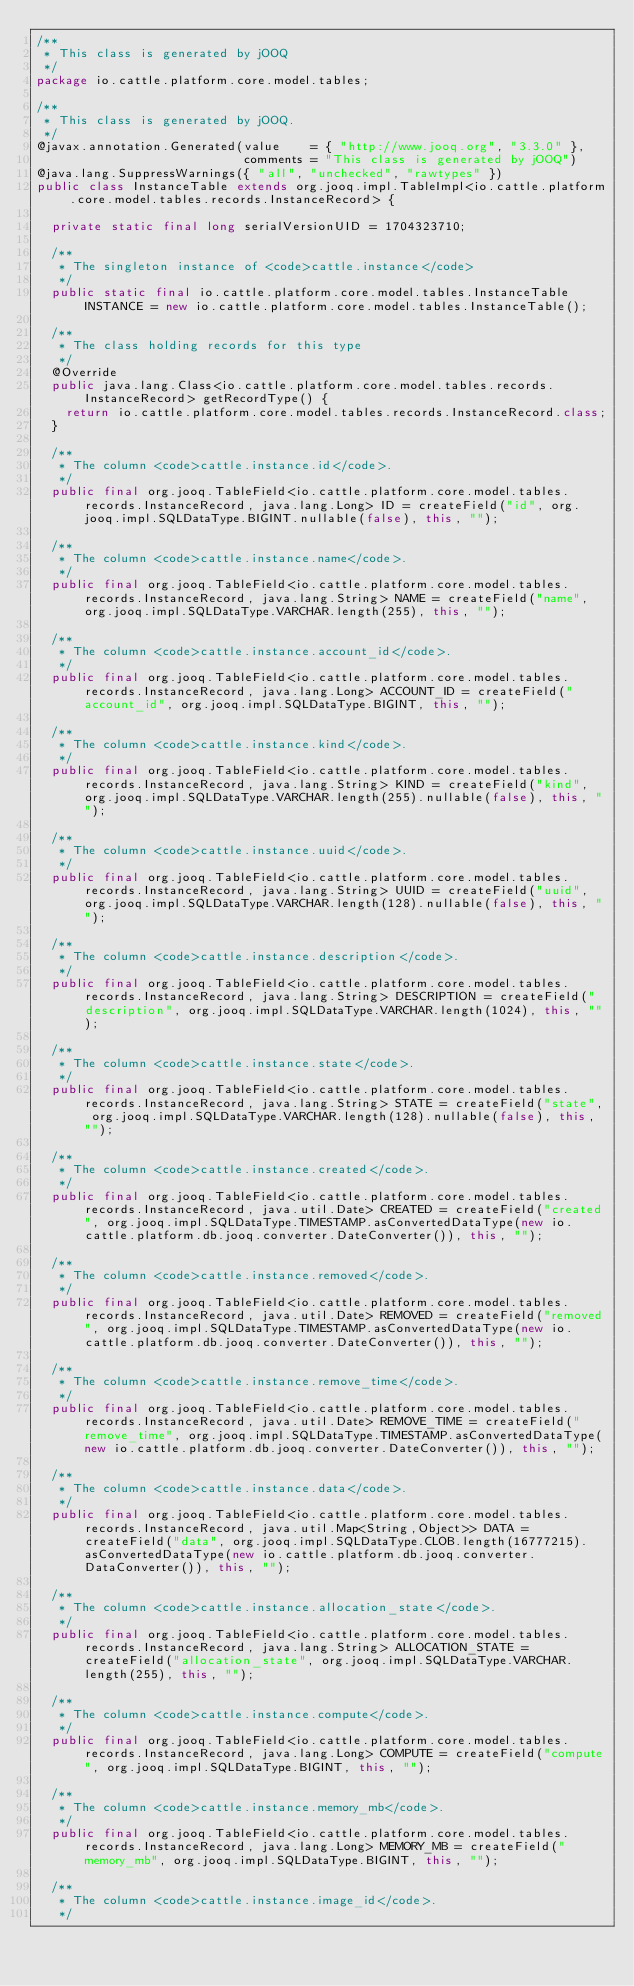<code> <loc_0><loc_0><loc_500><loc_500><_Java_>/**
 * This class is generated by jOOQ
 */
package io.cattle.platform.core.model.tables;

/**
 * This class is generated by jOOQ.
 */
@javax.annotation.Generated(value    = { "http://www.jooq.org", "3.3.0" },
                            comments = "This class is generated by jOOQ")
@java.lang.SuppressWarnings({ "all", "unchecked", "rawtypes" })
public class InstanceTable extends org.jooq.impl.TableImpl<io.cattle.platform.core.model.tables.records.InstanceRecord> {

	private static final long serialVersionUID = 1704323710;

	/**
	 * The singleton instance of <code>cattle.instance</code>
	 */
	public static final io.cattle.platform.core.model.tables.InstanceTable INSTANCE = new io.cattle.platform.core.model.tables.InstanceTable();

	/**
	 * The class holding records for this type
	 */
	@Override
	public java.lang.Class<io.cattle.platform.core.model.tables.records.InstanceRecord> getRecordType() {
		return io.cattle.platform.core.model.tables.records.InstanceRecord.class;
	}

	/**
	 * The column <code>cattle.instance.id</code>.
	 */
	public final org.jooq.TableField<io.cattle.platform.core.model.tables.records.InstanceRecord, java.lang.Long> ID = createField("id", org.jooq.impl.SQLDataType.BIGINT.nullable(false), this, "");

	/**
	 * The column <code>cattle.instance.name</code>.
	 */
	public final org.jooq.TableField<io.cattle.platform.core.model.tables.records.InstanceRecord, java.lang.String> NAME = createField("name", org.jooq.impl.SQLDataType.VARCHAR.length(255), this, "");

	/**
	 * The column <code>cattle.instance.account_id</code>.
	 */
	public final org.jooq.TableField<io.cattle.platform.core.model.tables.records.InstanceRecord, java.lang.Long> ACCOUNT_ID = createField("account_id", org.jooq.impl.SQLDataType.BIGINT, this, "");

	/**
	 * The column <code>cattle.instance.kind</code>.
	 */
	public final org.jooq.TableField<io.cattle.platform.core.model.tables.records.InstanceRecord, java.lang.String> KIND = createField("kind", org.jooq.impl.SQLDataType.VARCHAR.length(255).nullable(false), this, "");

	/**
	 * The column <code>cattle.instance.uuid</code>.
	 */
	public final org.jooq.TableField<io.cattle.platform.core.model.tables.records.InstanceRecord, java.lang.String> UUID = createField("uuid", org.jooq.impl.SQLDataType.VARCHAR.length(128).nullable(false), this, "");

	/**
	 * The column <code>cattle.instance.description</code>.
	 */
	public final org.jooq.TableField<io.cattle.platform.core.model.tables.records.InstanceRecord, java.lang.String> DESCRIPTION = createField("description", org.jooq.impl.SQLDataType.VARCHAR.length(1024), this, "");

	/**
	 * The column <code>cattle.instance.state</code>.
	 */
	public final org.jooq.TableField<io.cattle.platform.core.model.tables.records.InstanceRecord, java.lang.String> STATE = createField("state", org.jooq.impl.SQLDataType.VARCHAR.length(128).nullable(false), this, "");

	/**
	 * The column <code>cattle.instance.created</code>.
	 */
	public final org.jooq.TableField<io.cattle.platform.core.model.tables.records.InstanceRecord, java.util.Date> CREATED = createField("created", org.jooq.impl.SQLDataType.TIMESTAMP.asConvertedDataType(new io.cattle.platform.db.jooq.converter.DateConverter()), this, "");

	/**
	 * The column <code>cattle.instance.removed</code>.
	 */
	public final org.jooq.TableField<io.cattle.platform.core.model.tables.records.InstanceRecord, java.util.Date> REMOVED = createField("removed", org.jooq.impl.SQLDataType.TIMESTAMP.asConvertedDataType(new io.cattle.platform.db.jooq.converter.DateConverter()), this, "");

	/**
	 * The column <code>cattle.instance.remove_time</code>.
	 */
	public final org.jooq.TableField<io.cattle.platform.core.model.tables.records.InstanceRecord, java.util.Date> REMOVE_TIME = createField("remove_time", org.jooq.impl.SQLDataType.TIMESTAMP.asConvertedDataType(new io.cattle.platform.db.jooq.converter.DateConverter()), this, "");

	/**
	 * The column <code>cattle.instance.data</code>.
	 */
	public final org.jooq.TableField<io.cattle.platform.core.model.tables.records.InstanceRecord, java.util.Map<String,Object>> DATA = createField("data", org.jooq.impl.SQLDataType.CLOB.length(16777215).asConvertedDataType(new io.cattle.platform.db.jooq.converter.DataConverter()), this, "");

	/**
	 * The column <code>cattle.instance.allocation_state</code>.
	 */
	public final org.jooq.TableField<io.cattle.platform.core.model.tables.records.InstanceRecord, java.lang.String> ALLOCATION_STATE = createField("allocation_state", org.jooq.impl.SQLDataType.VARCHAR.length(255), this, "");

	/**
	 * The column <code>cattle.instance.compute</code>.
	 */
	public final org.jooq.TableField<io.cattle.platform.core.model.tables.records.InstanceRecord, java.lang.Long> COMPUTE = createField("compute", org.jooq.impl.SQLDataType.BIGINT, this, "");

	/**
	 * The column <code>cattle.instance.memory_mb</code>.
	 */
	public final org.jooq.TableField<io.cattle.platform.core.model.tables.records.InstanceRecord, java.lang.Long> MEMORY_MB = createField("memory_mb", org.jooq.impl.SQLDataType.BIGINT, this, "");

	/**
	 * The column <code>cattle.instance.image_id</code>.
	 */</code> 